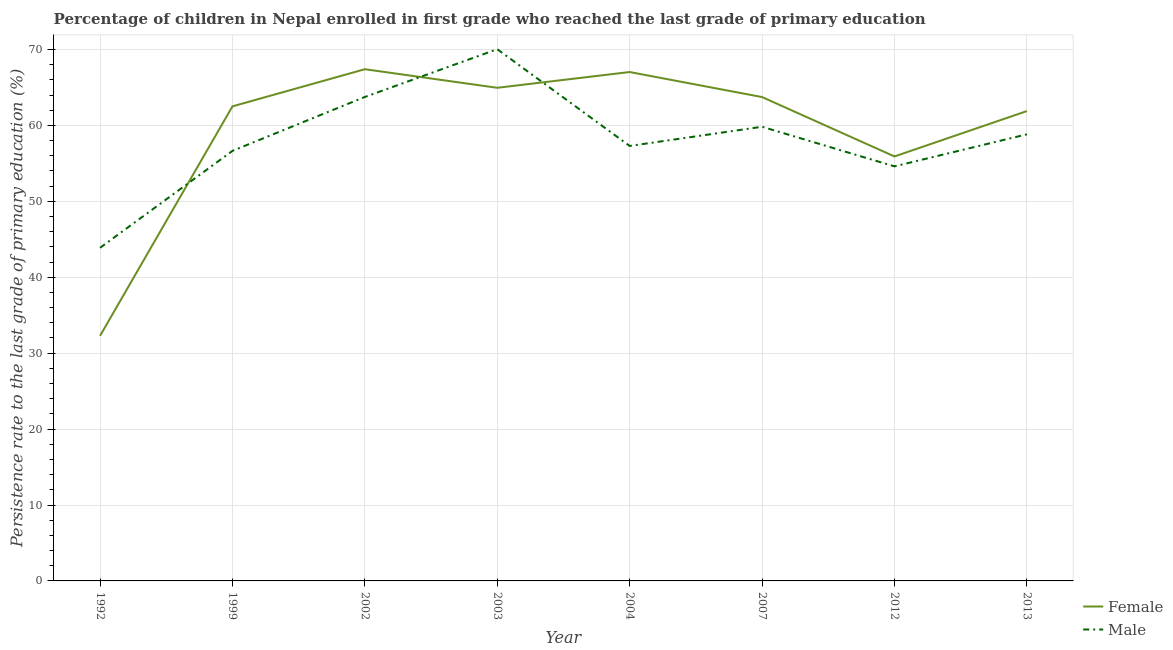How many different coloured lines are there?
Provide a short and direct response. 2. Does the line corresponding to persistence rate of female students intersect with the line corresponding to persistence rate of male students?
Your response must be concise. Yes. Is the number of lines equal to the number of legend labels?
Give a very brief answer. Yes. What is the persistence rate of male students in 1999?
Keep it short and to the point. 56.65. Across all years, what is the maximum persistence rate of female students?
Your answer should be compact. 67.41. Across all years, what is the minimum persistence rate of female students?
Your response must be concise. 32.28. In which year was the persistence rate of female students minimum?
Offer a terse response. 1992. What is the total persistence rate of male students in the graph?
Provide a short and direct response. 464.88. What is the difference between the persistence rate of female students in 2004 and that in 2007?
Ensure brevity in your answer.  3.3. What is the difference between the persistence rate of male students in 2004 and the persistence rate of female students in 2002?
Keep it short and to the point. -10.11. What is the average persistence rate of male students per year?
Your answer should be very brief. 58.11. In the year 2012, what is the difference between the persistence rate of female students and persistence rate of male students?
Provide a succinct answer. 1.31. In how many years, is the persistence rate of female students greater than 38 %?
Ensure brevity in your answer.  7. What is the ratio of the persistence rate of female students in 1992 to that in 2013?
Offer a terse response. 0.52. Is the persistence rate of male students in 1999 less than that in 2007?
Make the answer very short. Yes. What is the difference between the highest and the second highest persistence rate of male students?
Give a very brief answer. 6.29. What is the difference between the highest and the lowest persistence rate of female students?
Offer a very short reply. 35.12. In how many years, is the persistence rate of female students greater than the average persistence rate of female students taken over all years?
Your response must be concise. 6. Is the sum of the persistence rate of female students in 2003 and 2013 greater than the maximum persistence rate of male students across all years?
Give a very brief answer. Yes. Is the persistence rate of male students strictly less than the persistence rate of female students over the years?
Provide a short and direct response. No. How many lines are there?
Provide a short and direct response. 2. How many legend labels are there?
Provide a short and direct response. 2. How are the legend labels stacked?
Offer a very short reply. Vertical. What is the title of the graph?
Your answer should be compact. Percentage of children in Nepal enrolled in first grade who reached the last grade of primary education. Does "Non-pregnant women" appear as one of the legend labels in the graph?
Your response must be concise. No. What is the label or title of the Y-axis?
Give a very brief answer. Persistence rate to the last grade of primary education (%). What is the Persistence rate to the last grade of primary education (%) of Female in 1992?
Offer a very short reply. 32.28. What is the Persistence rate to the last grade of primary education (%) of Male in 1992?
Your answer should be very brief. 43.88. What is the Persistence rate to the last grade of primary education (%) in Female in 1999?
Provide a succinct answer. 62.51. What is the Persistence rate to the last grade of primary education (%) in Male in 1999?
Provide a succinct answer. 56.65. What is the Persistence rate to the last grade of primary education (%) of Female in 2002?
Offer a terse response. 67.41. What is the Persistence rate to the last grade of primary education (%) of Male in 2002?
Give a very brief answer. 63.75. What is the Persistence rate to the last grade of primary education (%) in Female in 2003?
Provide a short and direct response. 64.96. What is the Persistence rate to the last grade of primary education (%) in Male in 2003?
Your answer should be compact. 70.04. What is the Persistence rate to the last grade of primary education (%) in Female in 2004?
Give a very brief answer. 67.03. What is the Persistence rate to the last grade of primary education (%) in Male in 2004?
Your answer should be compact. 57.3. What is the Persistence rate to the last grade of primary education (%) in Female in 2007?
Make the answer very short. 63.74. What is the Persistence rate to the last grade of primary education (%) of Male in 2007?
Offer a terse response. 59.82. What is the Persistence rate to the last grade of primary education (%) in Female in 2012?
Ensure brevity in your answer.  55.91. What is the Persistence rate to the last grade of primary education (%) in Male in 2012?
Your response must be concise. 54.61. What is the Persistence rate to the last grade of primary education (%) of Female in 2013?
Your answer should be compact. 61.89. What is the Persistence rate to the last grade of primary education (%) in Male in 2013?
Offer a very short reply. 58.83. Across all years, what is the maximum Persistence rate to the last grade of primary education (%) of Female?
Provide a short and direct response. 67.41. Across all years, what is the maximum Persistence rate to the last grade of primary education (%) in Male?
Provide a succinct answer. 70.04. Across all years, what is the minimum Persistence rate to the last grade of primary education (%) in Female?
Offer a very short reply. 32.28. Across all years, what is the minimum Persistence rate to the last grade of primary education (%) in Male?
Give a very brief answer. 43.88. What is the total Persistence rate to the last grade of primary education (%) in Female in the graph?
Offer a terse response. 475.73. What is the total Persistence rate to the last grade of primary education (%) of Male in the graph?
Provide a short and direct response. 464.88. What is the difference between the Persistence rate to the last grade of primary education (%) of Female in 1992 and that in 1999?
Ensure brevity in your answer.  -30.23. What is the difference between the Persistence rate to the last grade of primary education (%) in Male in 1992 and that in 1999?
Ensure brevity in your answer.  -12.77. What is the difference between the Persistence rate to the last grade of primary education (%) in Female in 1992 and that in 2002?
Offer a very short reply. -35.12. What is the difference between the Persistence rate to the last grade of primary education (%) in Male in 1992 and that in 2002?
Offer a terse response. -19.87. What is the difference between the Persistence rate to the last grade of primary education (%) of Female in 1992 and that in 2003?
Make the answer very short. -32.67. What is the difference between the Persistence rate to the last grade of primary education (%) of Male in 1992 and that in 2003?
Make the answer very short. -26.16. What is the difference between the Persistence rate to the last grade of primary education (%) of Female in 1992 and that in 2004?
Offer a very short reply. -34.75. What is the difference between the Persistence rate to the last grade of primary education (%) of Male in 1992 and that in 2004?
Offer a very short reply. -13.42. What is the difference between the Persistence rate to the last grade of primary education (%) of Female in 1992 and that in 2007?
Give a very brief answer. -31.45. What is the difference between the Persistence rate to the last grade of primary education (%) in Male in 1992 and that in 2007?
Your response must be concise. -15.94. What is the difference between the Persistence rate to the last grade of primary education (%) of Female in 1992 and that in 2012?
Your answer should be compact. -23.63. What is the difference between the Persistence rate to the last grade of primary education (%) in Male in 1992 and that in 2012?
Ensure brevity in your answer.  -10.73. What is the difference between the Persistence rate to the last grade of primary education (%) in Female in 1992 and that in 2013?
Make the answer very short. -29.6. What is the difference between the Persistence rate to the last grade of primary education (%) in Male in 1992 and that in 2013?
Provide a succinct answer. -14.95. What is the difference between the Persistence rate to the last grade of primary education (%) in Female in 1999 and that in 2002?
Your answer should be very brief. -4.89. What is the difference between the Persistence rate to the last grade of primary education (%) of Male in 1999 and that in 2002?
Give a very brief answer. -7.1. What is the difference between the Persistence rate to the last grade of primary education (%) of Female in 1999 and that in 2003?
Your answer should be very brief. -2.45. What is the difference between the Persistence rate to the last grade of primary education (%) in Male in 1999 and that in 2003?
Provide a short and direct response. -13.39. What is the difference between the Persistence rate to the last grade of primary education (%) of Female in 1999 and that in 2004?
Give a very brief answer. -4.52. What is the difference between the Persistence rate to the last grade of primary education (%) of Male in 1999 and that in 2004?
Give a very brief answer. -0.65. What is the difference between the Persistence rate to the last grade of primary education (%) in Female in 1999 and that in 2007?
Your answer should be compact. -1.23. What is the difference between the Persistence rate to the last grade of primary education (%) of Male in 1999 and that in 2007?
Ensure brevity in your answer.  -3.18. What is the difference between the Persistence rate to the last grade of primary education (%) in Female in 1999 and that in 2012?
Provide a short and direct response. 6.6. What is the difference between the Persistence rate to the last grade of primary education (%) in Male in 1999 and that in 2012?
Keep it short and to the point. 2.04. What is the difference between the Persistence rate to the last grade of primary education (%) of Female in 1999 and that in 2013?
Provide a short and direct response. 0.62. What is the difference between the Persistence rate to the last grade of primary education (%) of Male in 1999 and that in 2013?
Make the answer very short. -2.18. What is the difference between the Persistence rate to the last grade of primary education (%) of Female in 2002 and that in 2003?
Make the answer very short. 2.45. What is the difference between the Persistence rate to the last grade of primary education (%) of Male in 2002 and that in 2003?
Your answer should be compact. -6.29. What is the difference between the Persistence rate to the last grade of primary education (%) of Female in 2002 and that in 2004?
Make the answer very short. 0.37. What is the difference between the Persistence rate to the last grade of primary education (%) of Male in 2002 and that in 2004?
Your answer should be compact. 6.45. What is the difference between the Persistence rate to the last grade of primary education (%) in Female in 2002 and that in 2007?
Give a very brief answer. 3.67. What is the difference between the Persistence rate to the last grade of primary education (%) of Male in 2002 and that in 2007?
Offer a very short reply. 3.93. What is the difference between the Persistence rate to the last grade of primary education (%) in Female in 2002 and that in 2012?
Your answer should be very brief. 11.49. What is the difference between the Persistence rate to the last grade of primary education (%) of Male in 2002 and that in 2012?
Your answer should be compact. 9.14. What is the difference between the Persistence rate to the last grade of primary education (%) of Female in 2002 and that in 2013?
Ensure brevity in your answer.  5.52. What is the difference between the Persistence rate to the last grade of primary education (%) of Male in 2002 and that in 2013?
Make the answer very short. 4.92. What is the difference between the Persistence rate to the last grade of primary education (%) of Female in 2003 and that in 2004?
Your response must be concise. -2.08. What is the difference between the Persistence rate to the last grade of primary education (%) of Male in 2003 and that in 2004?
Ensure brevity in your answer.  12.74. What is the difference between the Persistence rate to the last grade of primary education (%) of Female in 2003 and that in 2007?
Provide a succinct answer. 1.22. What is the difference between the Persistence rate to the last grade of primary education (%) in Male in 2003 and that in 2007?
Provide a short and direct response. 10.22. What is the difference between the Persistence rate to the last grade of primary education (%) of Female in 2003 and that in 2012?
Make the answer very short. 9.04. What is the difference between the Persistence rate to the last grade of primary education (%) in Male in 2003 and that in 2012?
Your response must be concise. 15.43. What is the difference between the Persistence rate to the last grade of primary education (%) of Female in 2003 and that in 2013?
Your answer should be compact. 3.07. What is the difference between the Persistence rate to the last grade of primary education (%) in Male in 2003 and that in 2013?
Keep it short and to the point. 11.21. What is the difference between the Persistence rate to the last grade of primary education (%) of Female in 2004 and that in 2007?
Offer a very short reply. 3.3. What is the difference between the Persistence rate to the last grade of primary education (%) of Male in 2004 and that in 2007?
Make the answer very short. -2.53. What is the difference between the Persistence rate to the last grade of primary education (%) in Female in 2004 and that in 2012?
Provide a succinct answer. 11.12. What is the difference between the Persistence rate to the last grade of primary education (%) of Male in 2004 and that in 2012?
Keep it short and to the point. 2.69. What is the difference between the Persistence rate to the last grade of primary education (%) in Female in 2004 and that in 2013?
Provide a short and direct response. 5.14. What is the difference between the Persistence rate to the last grade of primary education (%) of Male in 2004 and that in 2013?
Give a very brief answer. -1.53. What is the difference between the Persistence rate to the last grade of primary education (%) of Female in 2007 and that in 2012?
Provide a short and direct response. 7.82. What is the difference between the Persistence rate to the last grade of primary education (%) in Male in 2007 and that in 2012?
Provide a short and direct response. 5.22. What is the difference between the Persistence rate to the last grade of primary education (%) in Female in 2007 and that in 2013?
Provide a succinct answer. 1.85. What is the difference between the Persistence rate to the last grade of primary education (%) of Male in 2007 and that in 2013?
Provide a short and direct response. 1. What is the difference between the Persistence rate to the last grade of primary education (%) of Female in 2012 and that in 2013?
Keep it short and to the point. -5.98. What is the difference between the Persistence rate to the last grade of primary education (%) in Male in 2012 and that in 2013?
Provide a short and direct response. -4.22. What is the difference between the Persistence rate to the last grade of primary education (%) of Female in 1992 and the Persistence rate to the last grade of primary education (%) of Male in 1999?
Provide a short and direct response. -24.36. What is the difference between the Persistence rate to the last grade of primary education (%) in Female in 1992 and the Persistence rate to the last grade of primary education (%) in Male in 2002?
Your answer should be very brief. -31.47. What is the difference between the Persistence rate to the last grade of primary education (%) in Female in 1992 and the Persistence rate to the last grade of primary education (%) in Male in 2003?
Ensure brevity in your answer.  -37.76. What is the difference between the Persistence rate to the last grade of primary education (%) of Female in 1992 and the Persistence rate to the last grade of primary education (%) of Male in 2004?
Your response must be concise. -25.01. What is the difference between the Persistence rate to the last grade of primary education (%) in Female in 1992 and the Persistence rate to the last grade of primary education (%) in Male in 2007?
Offer a terse response. -27.54. What is the difference between the Persistence rate to the last grade of primary education (%) in Female in 1992 and the Persistence rate to the last grade of primary education (%) in Male in 2012?
Your answer should be very brief. -22.32. What is the difference between the Persistence rate to the last grade of primary education (%) in Female in 1992 and the Persistence rate to the last grade of primary education (%) in Male in 2013?
Provide a short and direct response. -26.54. What is the difference between the Persistence rate to the last grade of primary education (%) of Female in 1999 and the Persistence rate to the last grade of primary education (%) of Male in 2002?
Make the answer very short. -1.24. What is the difference between the Persistence rate to the last grade of primary education (%) of Female in 1999 and the Persistence rate to the last grade of primary education (%) of Male in 2003?
Provide a succinct answer. -7.53. What is the difference between the Persistence rate to the last grade of primary education (%) of Female in 1999 and the Persistence rate to the last grade of primary education (%) of Male in 2004?
Offer a very short reply. 5.22. What is the difference between the Persistence rate to the last grade of primary education (%) in Female in 1999 and the Persistence rate to the last grade of primary education (%) in Male in 2007?
Offer a terse response. 2.69. What is the difference between the Persistence rate to the last grade of primary education (%) of Female in 1999 and the Persistence rate to the last grade of primary education (%) of Male in 2012?
Keep it short and to the point. 7.9. What is the difference between the Persistence rate to the last grade of primary education (%) in Female in 1999 and the Persistence rate to the last grade of primary education (%) in Male in 2013?
Your response must be concise. 3.68. What is the difference between the Persistence rate to the last grade of primary education (%) in Female in 2002 and the Persistence rate to the last grade of primary education (%) in Male in 2003?
Offer a terse response. -2.63. What is the difference between the Persistence rate to the last grade of primary education (%) in Female in 2002 and the Persistence rate to the last grade of primary education (%) in Male in 2004?
Offer a terse response. 10.11. What is the difference between the Persistence rate to the last grade of primary education (%) of Female in 2002 and the Persistence rate to the last grade of primary education (%) of Male in 2007?
Offer a very short reply. 7.58. What is the difference between the Persistence rate to the last grade of primary education (%) in Female in 2002 and the Persistence rate to the last grade of primary education (%) in Male in 2012?
Offer a very short reply. 12.8. What is the difference between the Persistence rate to the last grade of primary education (%) of Female in 2002 and the Persistence rate to the last grade of primary education (%) of Male in 2013?
Provide a succinct answer. 8.58. What is the difference between the Persistence rate to the last grade of primary education (%) in Female in 2003 and the Persistence rate to the last grade of primary education (%) in Male in 2004?
Your response must be concise. 7.66. What is the difference between the Persistence rate to the last grade of primary education (%) in Female in 2003 and the Persistence rate to the last grade of primary education (%) in Male in 2007?
Make the answer very short. 5.13. What is the difference between the Persistence rate to the last grade of primary education (%) in Female in 2003 and the Persistence rate to the last grade of primary education (%) in Male in 2012?
Give a very brief answer. 10.35. What is the difference between the Persistence rate to the last grade of primary education (%) in Female in 2003 and the Persistence rate to the last grade of primary education (%) in Male in 2013?
Provide a succinct answer. 6.13. What is the difference between the Persistence rate to the last grade of primary education (%) of Female in 2004 and the Persistence rate to the last grade of primary education (%) of Male in 2007?
Your answer should be very brief. 7.21. What is the difference between the Persistence rate to the last grade of primary education (%) in Female in 2004 and the Persistence rate to the last grade of primary education (%) in Male in 2012?
Your answer should be compact. 12.43. What is the difference between the Persistence rate to the last grade of primary education (%) in Female in 2004 and the Persistence rate to the last grade of primary education (%) in Male in 2013?
Make the answer very short. 8.21. What is the difference between the Persistence rate to the last grade of primary education (%) of Female in 2007 and the Persistence rate to the last grade of primary education (%) of Male in 2012?
Your answer should be compact. 9.13. What is the difference between the Persistence rate to the last grade of primary education (%) in Female in 2007 and the Persistence rate to the last grade of primary education (%) in Male in 2013?
Offer a very short reply. 4.91. What is the difference between the Persistence rate to the last grade of primary education (%) of Female in 2012 and the Persistence rate to the last grade of primary education (%) of Male in 2013?
Your response must be concise. -2.91. What is the average Persistence rate to the last grade of primary education (%) in Female per year?
Give a very brief answer. 59.47. What is the average Persistence rate to the last grade of primary education (%) of Male per year?
Offer a terse response. 58.11. In the year 1992, what is the difference between the Persistence rate to the last grade of primary education (%) in Female and Persistence rate to the last grade of primary education (%) in Male?
Your response must be concise. -11.6. In the year 1999, what is the difference between the Persistence rate to the last grade of primary education (%) in Female and Persistence rate to the last grade of primary education (%) in Male?
Offer a very short reply. 5.86. In the year 2002, what is the difference between the Persistence rate to the last grade of primary education (%) of Female and Persistence rate to the last grade of primary education (%) of Male?
Your answer should be compact. 3.66. In the year 2003, what is the difference between the Persistence rate to the last grade of primary education (%) of Female and Persistence rate to the last grade of primary education (%) of Male?
Your answer should be very brief. -5.08. In the year 2004, what is the difference between the Persistence rate to the last grade of primary education (%) of Female and Persistence rate to the last grade of primary education (%) of Male?
Offer a terse response. 9.74. In the year 2007, what is the difference between the Persistence rate to the last grade of primary education (%) in Female and Persistence rate to the last grade of primary education (%) in Male?
Provide a succinct answer. 3.91. In the year 2012, what is the difference between the Persistence rate to the last grade of primary education (%) in Female and Persistence rate to the last grade of primary education (%) in Male?
Make the answer very short. 1.31. In the year 2013, what is the difference between the Persistence rate to the last grade of primary education (%) in Female and Persistence rate to the last grade of primary education (%) in Male?
Your answer should be very brief. 3.06. What is the ratio of the Persistence rate to the last grade of primary education (%) in Female in 1992 to that in 1999?
Offer a very short reply. 0.52. What is the ratio of the Persistence rate to the last grade of primary education (%) of Male in 1992 to that in 1999?
Offer a terse response. 0.77. What is the ratio of the Persistence rate to the last grade of primary education (%) in Female in 1992 to that in 2002?
Your response must be concise. 0.48. What is the ratio of the Persistence rate to the last grade of primary education (%) of Male in 1992 to that in 2002?
Your answer should be very brief. 0.69. What is the ratio of the Persistence rate to the last grade of primary education (%) of Female in 1992 to that in 2003?
Your response must be concise. 0.5. What is the ratio of the Persistence rate to the last grade of primary education (%) of Male in 1992 to that in 2003?
Provide a short and direct response. 0.63. What is the ratio of the Persistence rate to the last grade of primary education (%) in Female in 1992 to that in 2004?
Offer a very short reply. 0.48. What is the ratio of the Persistence rate to the last grade of primary education (%) of Male in 1992 to that in 2004?
Offer a very short reply. 0.77. What is the ratio of the Persistence rate to the last grade of primary education (%) of Female in 1992 to that in 2007?
Make the answer very short. 0.51. What is the ratio of the Persistence rate to the last grade of primary education (%) of Male in 1992 to that in 2007?
Offer a terse response. 0.73. What is the ratio of the Persistence rate to the last grade of primary education (%) in Female in 1992 to that in 2012?
Give a very brief answer. 0.58. What is the ratio of the Persistence rate to the last grade of primary education (%) in Male in 1992 to that in 2012?
Make the answer very short. 0.8. What is the ratio of the Persistence rate to the last grade of primary education (%) in Female in 1992 to that in 2013?
Your answer should be very brief. 0.52. What is the ratio of the Persistence rate to the last grade of primary education (%) of Male in 1992 to that in 2013?
Make the answer very short. 0.75. What is the ratio of the Persistence rate to the last grade of primary education (%) of Female in 1999 to that in 2002?
Make the answer very short. 0.93. What is the ratio of the Persistence rate to the last grade of primary education (%) in Male in 1999 to that in 2002?
Your answer should be compact. 0.89. What is the ratio of the Persistence rate to the last grade of primary education (%) in Female in 1999 to that in 2003?
Provide a succinct answer. 0.96. What is the ratio of the Persistence rate to the last grade of primary education (%) of Male in 1999 to that in 2003?
Keep it short and to the point. 0.81. What is the ratio of the Persistence rate to the last grade of primary education (%) of Female in 1999 to that in 2004?
Your response must be concise. 0.93. What is the ratio of the Persistence rate to the last grade of primary education (%) of Male in 1999 to that in 2004?
Provide a short and direct response. 0.99. What is the ratio of the Persistence rate to the last grade of primary education (%) of Female in 1999 to that in 2007?
Your answer should be compact. 0.98. What is the ratio of the Persistence rate to the last grade of primary education (%) in Male in 1999 to that in 2007?
Provide a succinct answer. 0.95. What is the ratio of the Persistence rate to the last grade of primary education (%) of Female in 1999 to that in 2012?
Offer a terse response. 1.12. What is the ratio of the Persistence rate to the last grade of primary education (%) of Male in 1999 to that in 2012?
Make the answer very short. 1.04. What is the ratio of the Persistence rate to the last grade of primary education (%) of Male in 1999 to that in 2013?
Provide a succinct answer. 0.96. What is the ratio of the Persistence rate to the last grade of primary education (%) in Female in 2002 to that in 2003?
Make the answer very short. 1.04. What is the ratio of the Persistence rate to the last grade of primary education (%) in Male in 2002 to that in 2003?
Your response must be concise. 0.91. What is the ratio of the Persistence rate to the last grade of primary education (%) of Male in 2002 to that in 2004?
Give a very brief answer. 1.11. What is the ratio of the Persistence rate to the last grade of primary education (%) of Female in 2002 to that in 2007?
Your response must be concise. 1.06. What is the ratio of the Persistence rate to the last grade of primary education (%) of Male in 2002 to that in 2007?
Make the answer very short. 1.07. What is the ratio of the Persistence rate to the last grade of primary education (%) of Female in 2002 to that in 2012?
Offer a terse response. 1.21. What is the ratio of the Persistence rate to the last grade of primary education (%) in Male in 2002 to that in 2012?
Keep it short and to the point. 1.17. What is the ratio of the Persistence rate to the last grade of primary education (%) of Female in 2002 to that in 2013?
Provide a succinct answer. 1.09. What is the ratio of the Persistence rate to the last grade of primary education (%) in Male in 2002 to that in 2013?
Ensure brevity in your answer.  1.08. What is the ratio of the Persistence rate to the last grade of primary education (%) in Male in 2003 to that in 2004?
Your response must be concise. 1.22. What is the ratio of the Persistence rate to the last grade of primary education (%) in Female in 2003 to that in 2007?
Your answer should be compact. 1.02. What is the ratio of the Persistence rate to the last grade of primary education (%) of Male in 2003 to that in 2007?
Give a very brief answer. 1.17. What is the ratio of the Persistence rate to the last grade of primary education (%) of Female in 2003 to that in 2012?
Give a very brief answer. 1.16. What is the ratio of the Persistence rate to the last grade of primary education (%) in Male in 2003 to that in 2012?
Offer a terse response. 1.28. What is the ratio of the Persistence rate to the last grade of primary education (%) in Female in 2003 to that in 2013?
Give a very brief answer. 1.05. What is the ratio of the Persistence rate to the last grade of primary education (%) of Male in 2003 to that in 2013?
Ensure brevity in your answer.  1.19. What is the ratio of the Persistence rate to the last grade of primary education (%) in Female in 2004 to that in 2007?
Keep it short and to the point. 1.05. What is the ratio of the Persistence rate to the last grade of primary education (%) of Male in 2004 to that in 2007?
Your answer should be very brief. 0.96. What is the ratio of the Persistence rate to the last grade of primary education (%) in Female in 2004 to that in 2012?
Your answer should be very brief. 1.2. What is the ratio of the Persistence rate to the last grade of primary education (%) of Male in 2004 to that in 2012?
Offer a terse response. 1.05. What is the ratio of the Persistence rate to the last grade of primary education (%) in Female in 2004 to that in 2013?
Provide a succinct answer. 1.08. What is the ratio of the Persistence rate to the last grade of primary education (%) in Female in 2007 to that in 2012?
Give a very brief answer. 1.14. What is the ratio of the Persistence rate to the last grade of primary education (%) in Male in 2007 to that in 2012?
Ensure brevity in your answer.  1.1. What is the ratio of the Persistence rate to the last grade of primary education (%) of Female in 2007 to that in 2013?
Your response must be concise. 1.03. What is the ratio of the Persistence rate to the last grade of primary education (%) of Male in 2007 to that in 2013?
Your response must be concise. 1.02. What is the ratio of the Persistence rate to the last grade of primary education (%) of Female in 2012 to that in 2013?
Your response must be concise. 0.9. What is the ratio of the Persistence rate to the last grade of primary education (%) in Male in 2012 to that in 2013?
Offer a terse response. 0.93. What is the difference between the highest and the second highest Persistence rate to the last grade of primary education (%) in Female?
Make the answer very short. 0.37. What is the difference between the highest and the second highest Persistence rate to the last grade of primary education (%) in Male?
Offer a very short reply. 6.29. What is the difference between the highest and the lowest Persistence rate to the last grade of primary education (%) of Female?
Give a very brief answer. 35.12. What is the difference between the highest and the lowest Persistence rate to the last grade of primary education (%) of Male?
Your response must be concise. 26.16. 